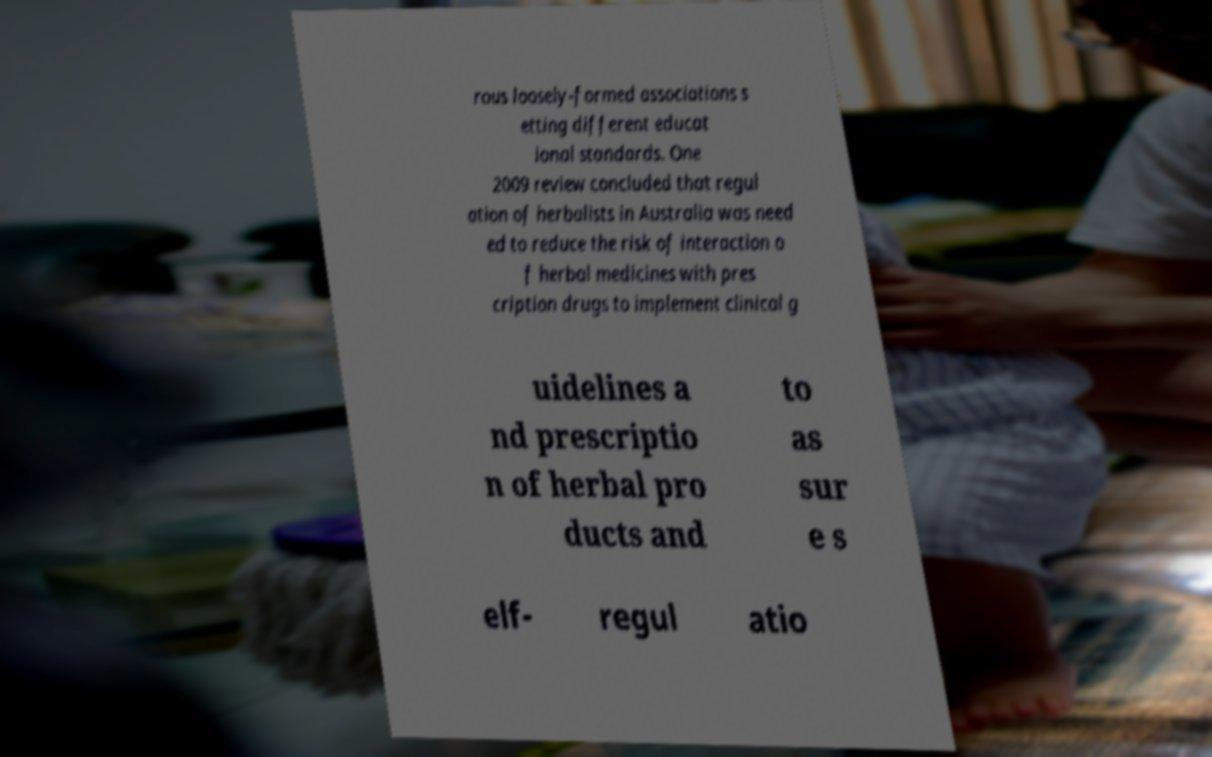Can you read and provide the text displayed in the image?This photo seems to have some interesting text. Can you extract and type it out for me? rous loosely-formed associations s etting different educat ional standards. One 2009 review concluded that regul ation of herbalists in Australia was need ed to reduce the risk of interaction o f herbal medicines with pres cription drugs to implement clinical g uidelines a nd prescriptio n of herbal pro ducts and to as sur e s elf- regul atio 